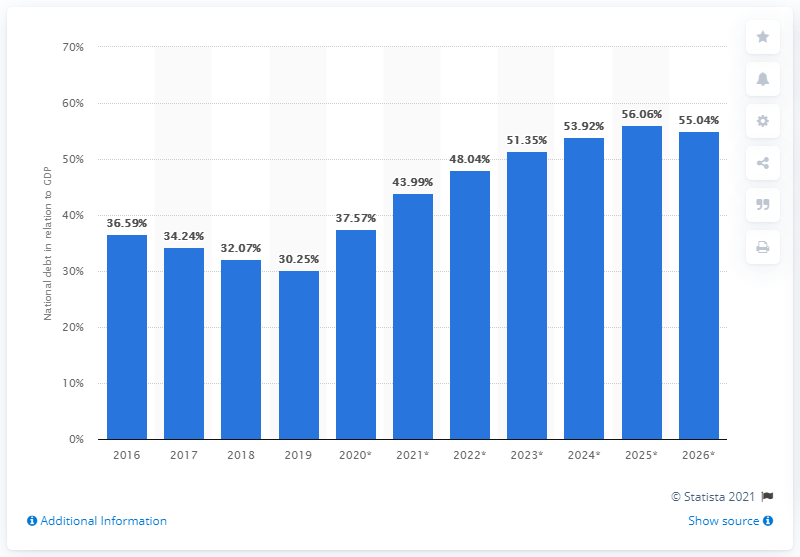Point out several critical features in this image. In 2019, the national debt of the Czech Republic accounted for 30.25% of the country's Gross Domestic Product (GDP). 